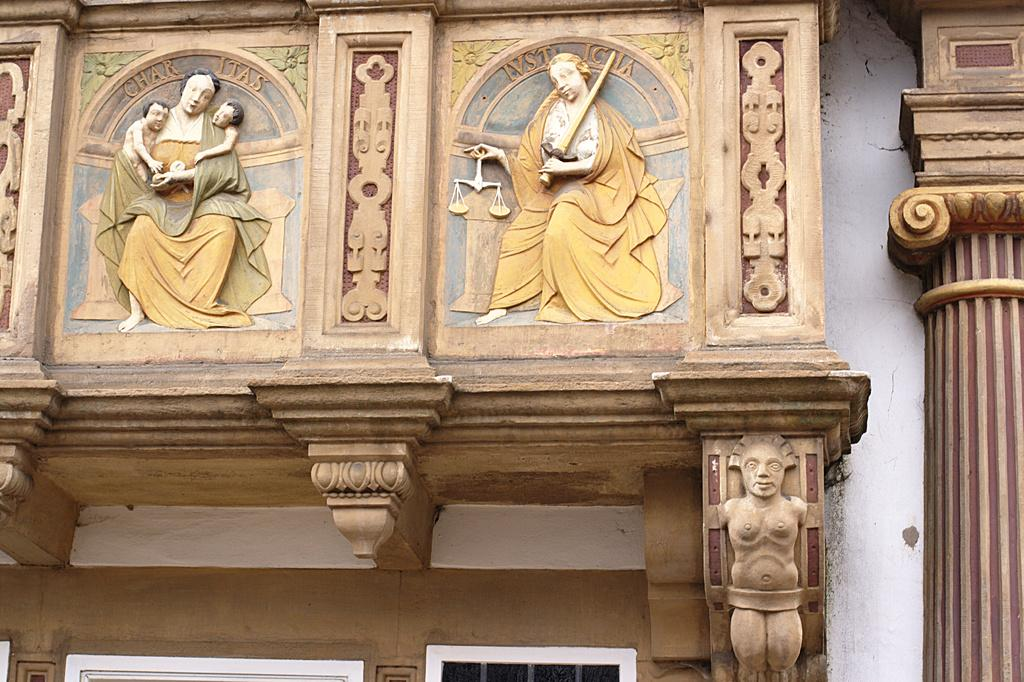What can be seen on the wall in the image? There are sculptures on the wall in the image. What architectural feature is present in the image? There is a pillar in the image. Can you describe any objects in the image? Yes, there are some objects in the image. What news is being reported by the cow in the image? There is no cow present in the image, and therefore no news can be reported. What type of apparel is the sculpture wearing in the image? The provided facts do not mention any apparel worn by the sculptures in the image. 